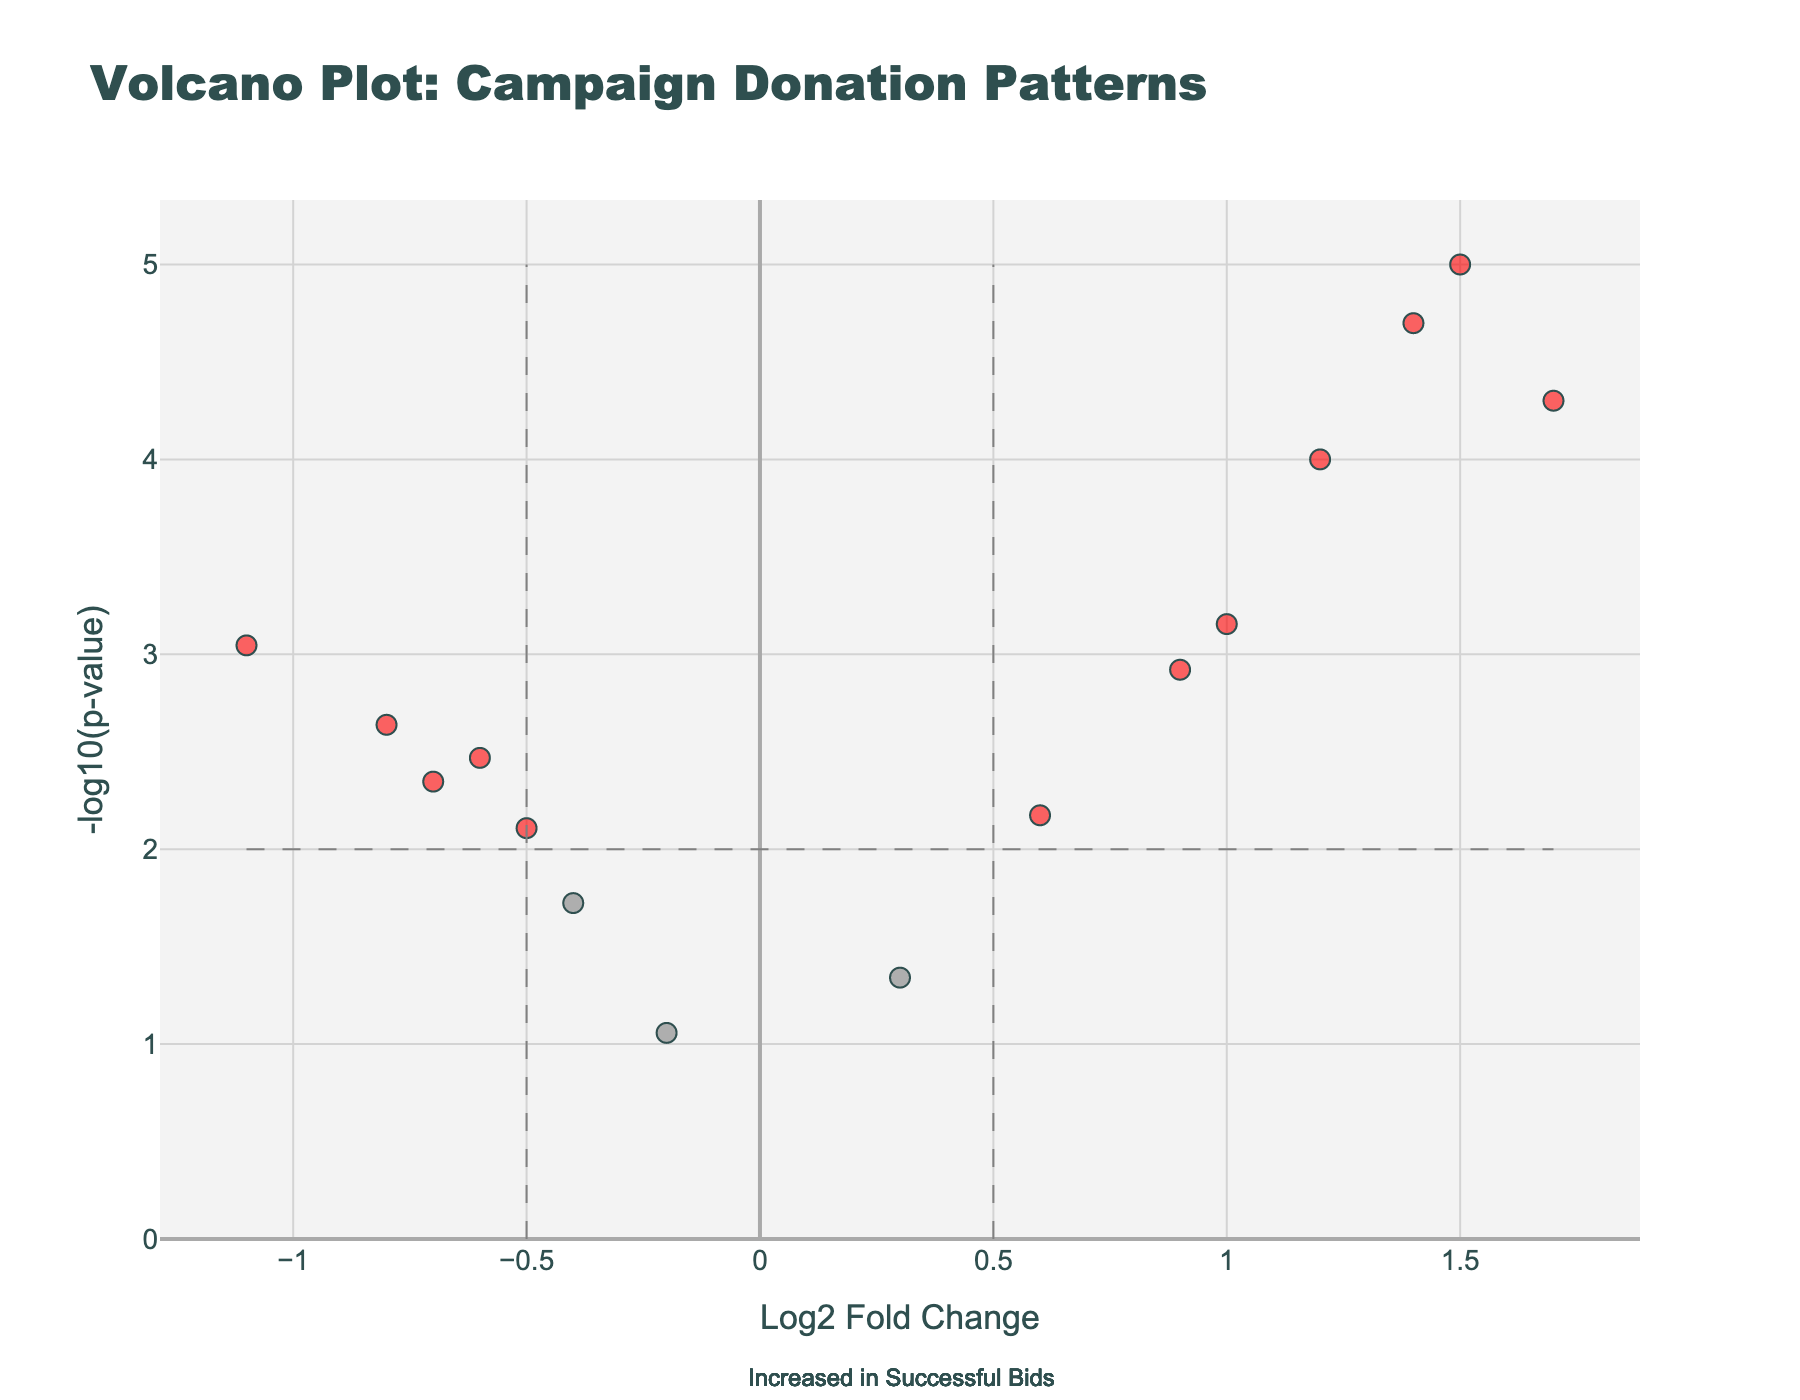What is the title of the figure? The title is usually prominently displayed at the top of the figure. It helps give context about what the visualization is showing. Just looking at the top of the figure, we see it is labeled "Volcano Plot: Campaign Donation Patterns."
Answer: Volcano Plot: Campaign Donation Patterns How many data points are marked as significant in the plot? To determine this, we look at those points with both a high -log10(p-value) and significant fold change values, which are usually highlighted in a different color. These points are labeled with their gene names. By counting, we see there are 10 significant data points.
Answer: 10 What does a point located at a high positive Log2 Fold Change and high -log10(p-value) represent? In a volcano plot, a high positive Log2 Fold Change indicates a higher increase in donations for successful bids compared to unsuccessful ones. The high -log10(p-value) shows this difference is statistically significant. High values in both axes indicate strong and significant increase in donors for successful bids. For instance, "Dark Money Groups" has both high values, suggesting it's a major significant increase.
Answer: Major significant increase for successful bids Which category has the highest negative Log2 Fold Change value and what does it mean? To find this, we locate the point with the most negative Log2 Fold Change. The point for "Self-Funding" is at -1.1 Log2 Fold Change, indicating self-funding is significantly higher in unsuccessful bids compared to successful bids. The meaning is that unsuccessful candidates rely more on self-funding.
Answer: Self-Funding; higher in unsuccessful bids Compare the fold change for Corporate PACs and Labor Unions. Which has a higher Log2 Fold Change and what does that imply? Locate the data points for both “Corporate PACs” and “Labor Unions” on the graph. Corporate PACs have a Log2 Fold Change of 1.2, while Labor Unions have -0.5. This means Corporate PACs have a higher increase in successful bids compared to unsuccessful ones, while Labor Unions tend to support unsuccessful bids more.
Answer: Corporate PACs; more increase in successful bids What is indicated by points plotted on the right side of the figure? In a volcano plot, points on the right side (positive Log2 Fold Change) indicate elements or donors that are more prevalent in successful election bids. This implies that donors located towards the right contribute more to successful campaigns.
Answer: More prevalent in successful bids Which categories fall under Log2 Fold Change between -0.5 and 0.5 and what does their placement signify? By examining the central portion of the plot between -0.5 and 0.5 on the x-axis, we find points like "Party Committees" and "Religious Groups." Their placement signifies that these categories do not significantly differ in donations between successful and unsuccessful bids. They provide balanced support irrespective of the outcomes.
Answer: Party Committees, Religious Groups; balanced support What can be inferred about “Lobbyists” from the plot? Locate “Lobbyists” on the plot. It has a high positive Log2 Fold Change (1.4) and a low p-value (very high -log10(p-value)). This infers that lobbyist donations are substantially higher in successful election bids and the difference is highly significant.
Answer: Substantially higher in successful bids What is the significance threshold for the p-value used in this plot and was it met by "Celebrity Endorsements"? We can infer from the shape layout, where the horizontal dashed line represents the significance threshold of 2 on the -log10(p-value) axis, which equates to a p-value of 0.01. Checking the position for "Celebrity Endorsements," its -log10(p-value) is lower than 2, meaning it did not meet the significance threshold.
Answer: 0.01; not met by Celebrity Endorsements Why might the plot have two vertical dashed lines? The vertical dashed lines generally represent thresholds for significant Log2 Fold Change values. In this plot, they are at -0.5 and 0.5. These lines are likely set to distinguish between donations that significantly favor successful or unsuccessful bids. Donor categories outside these lines show notable differences between successful and unsuccessful bids.
Answer: To distinguish significant Log2 Fold Changes 